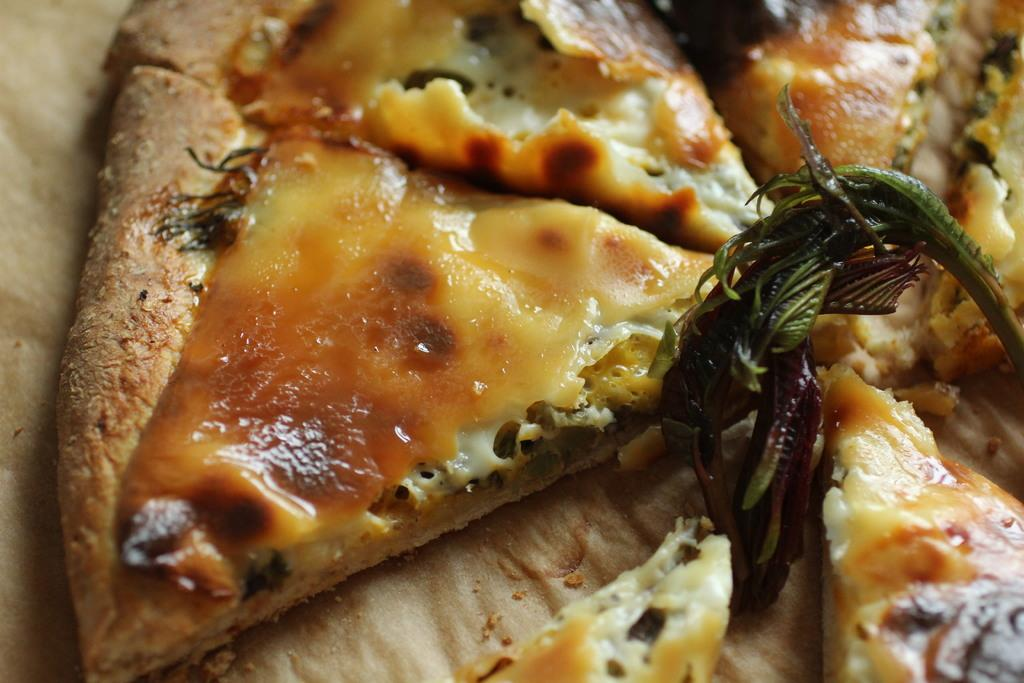What is the main subject in the center of the image? There is a food item in the center of the image. What type of sofa is visible in the image? There is no sofa present in the image; it only features a food item in the center. 